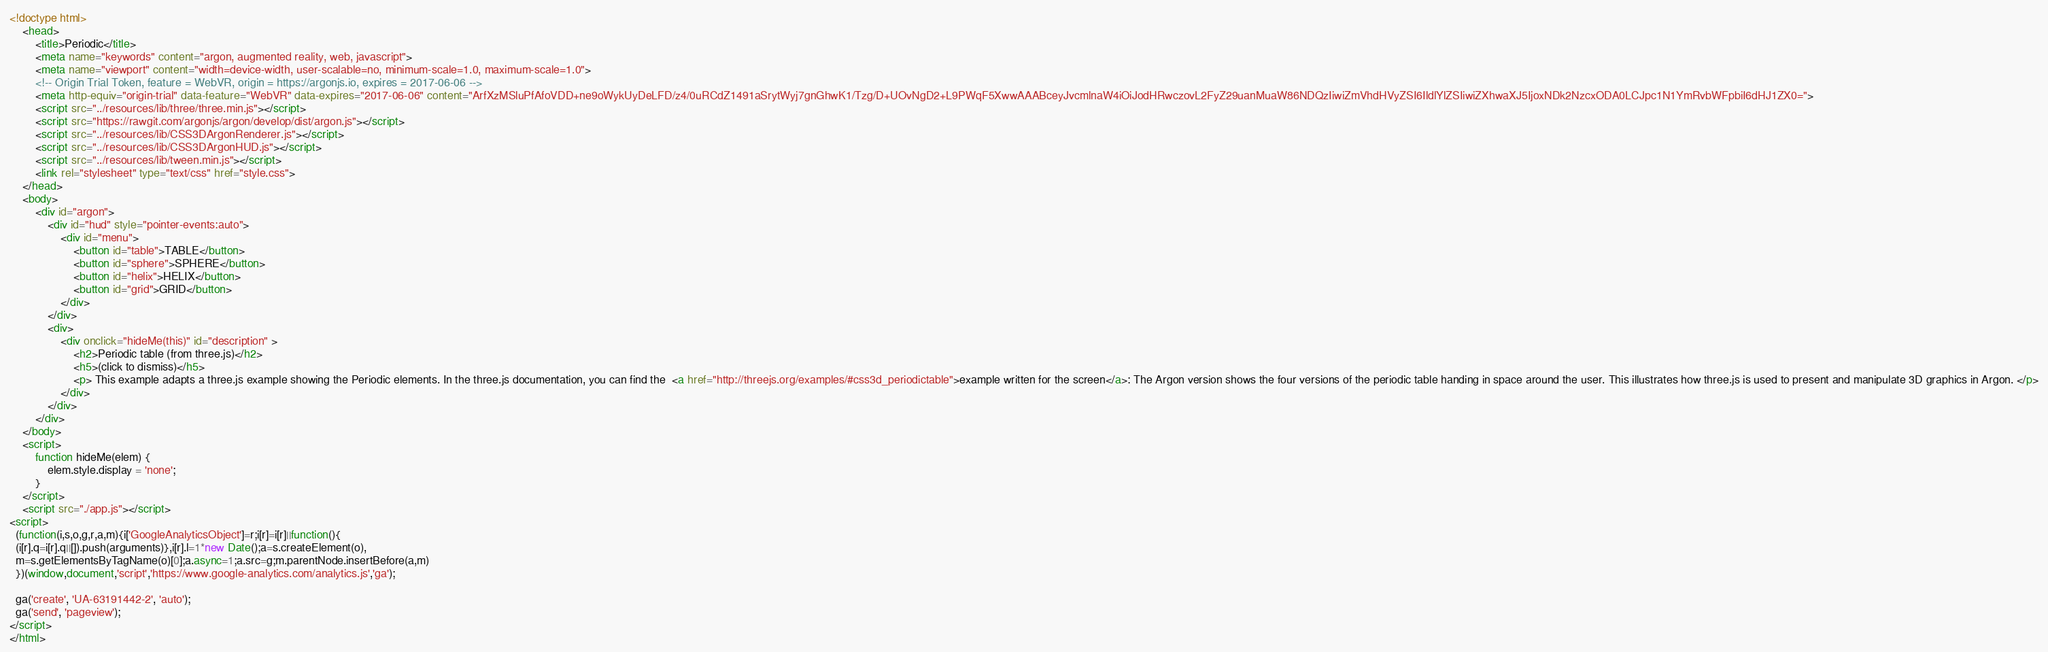Convert code to text. <code><loc_0><loc_0><loc_500><loc_500><_HTML_><!doctype html>
    <head>	
		<title>Periodic</title>
	  	<meta name="keywords" content="argon, augmented reality, web, javascript">
		<meta name="viewport" content="width=device-width, user-scalable=no, minimum-scale=1.0, maximum-scale=1.0">
	    <!-- Origin Trial Token, feature = WebVR, origin = https://argonjs.io, expires = 2017-06-06 -->
    	<meta http-equiv="origin-trial" data-feature="WebVR" data-expires="2017-06-06" content="ArfXzMSluPfAfoVDD+ne9oWykUyDeLFD/z4/0uRCdZ1491aSrytWyj7gnGhwK1/Tzg/D+UOvNgD2+L9PWqF5XwwAAABceyJvcmlnaW4iOiJodHRwczovL2FyZ29uanMuaW86NDQzIiwiZmVhdHVyZSI6IldlYlZSIiwiZXhwaXJ5IjoxNDk2NzcxODA0LCJpc1N1YmRvbWFpbiI6dHJ1ZX0=">
		<script src="../resources/lib/three/three.min.js"></script>
		<script src="https://rawgit.com/argonjs/argon/develop/dist/argon.js"></script>
		<script src="../resources/lib/CSS3DArgonRenderer.js"></script>
		<script src="../resources/lib/CSS3DArgonHUD.js"></script>
		<script src="../resources/lib/tween.min.js"></script>
		<link rel="stylesheet" type="text/css" href="style.css">
	</head>
	<body>
		<div id="argon">
			<div id="hud" style="pointer-events:auto">
				<div id="menu">
					<button id="table">TABLE</button>
					<button id="sphere">SPHERE</button>
					<button id="helix">HELIX</button>
					<button id="grid">GRID</button>
				</div>
			</div>
			<div>
				<div onclick="hideMe(this)" id="description" >
					<h2>Periodic table (from three.js)</h2>
					<h5>(click to dismiss)</h5>
					<p> This example adapts a three.js example showing the Periodic elements. In the three.js documentation, you can find the  <a href="http://threejs.org/examples/#css3d_periodictable">example written for the screen</a>: The Argon version shows the four versions of the periodic table handing in space around the user. This illustrates how three.js is used to present and manipulate 3D graphics in Argon. </p>
				</div>
			</div>
		</div>
	</body>
	<script>
		function hideMe(elem) {
		    elem.style.display = 'none';
		}	
	</script>
    <script src="./app.js"></script>
<script>
  (function(i,s,o,g,r,a,m){i['GoogleAnalyticsObject']=r;i[r]=i[r]||function(){
  (i[r].q=i[r].q||[]).push(arguments)},i[r].l=1*new Date();a=s.createElement(o),
  m=s.getElementsByTagName(o)[0];a.async=1;a.src=g;m.parentNode.insertBefore(a,m)
  })(window,document,'script','https://www.google-analytics.com/analytics.js','ga');

  ga('create', 'UA-63191442-2', 'auto');
  ga('send', 'pageview');
</script>  	
</html></code> 